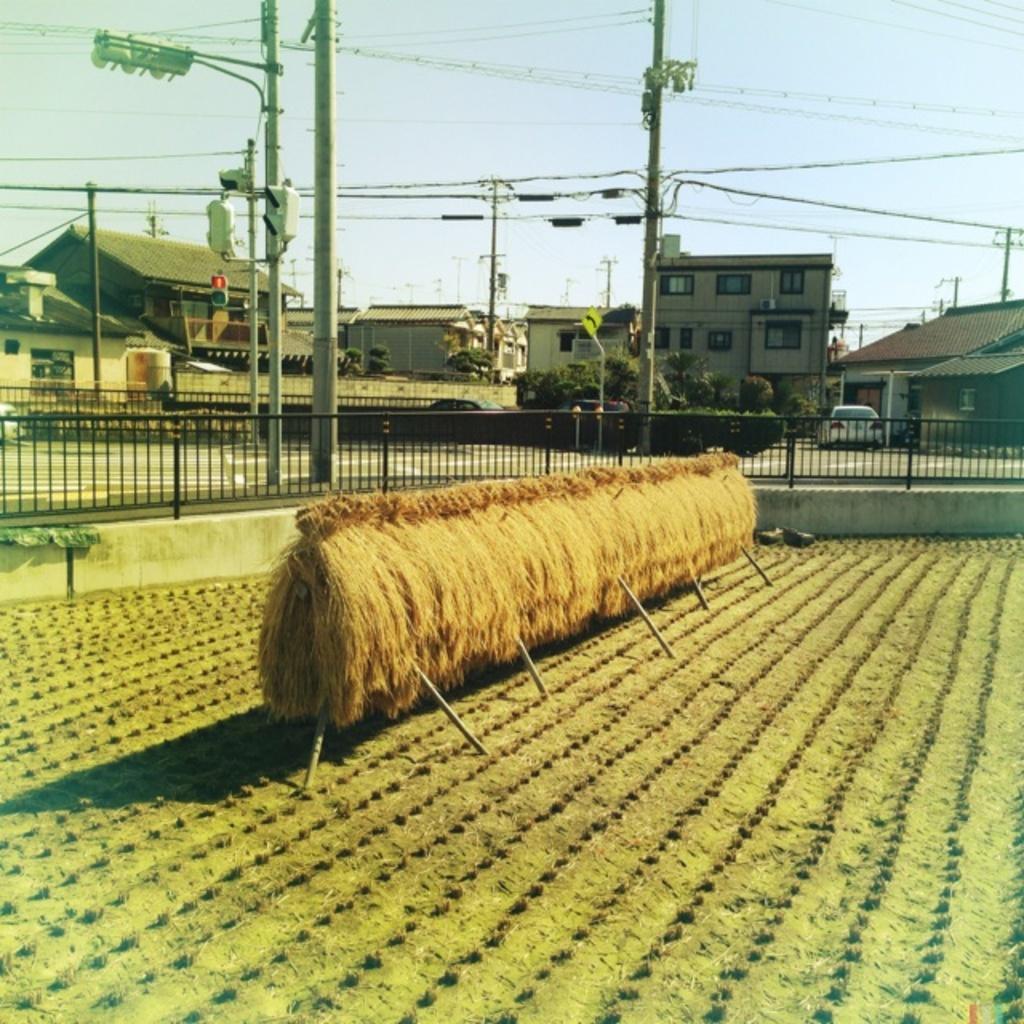Can you describe this image briefly? In this picture I can observe straw which is an agricultural byproduct in the middle of the picture. I can observe black color railing behind the straw. In the background I can observe buildings, wires and sky. 